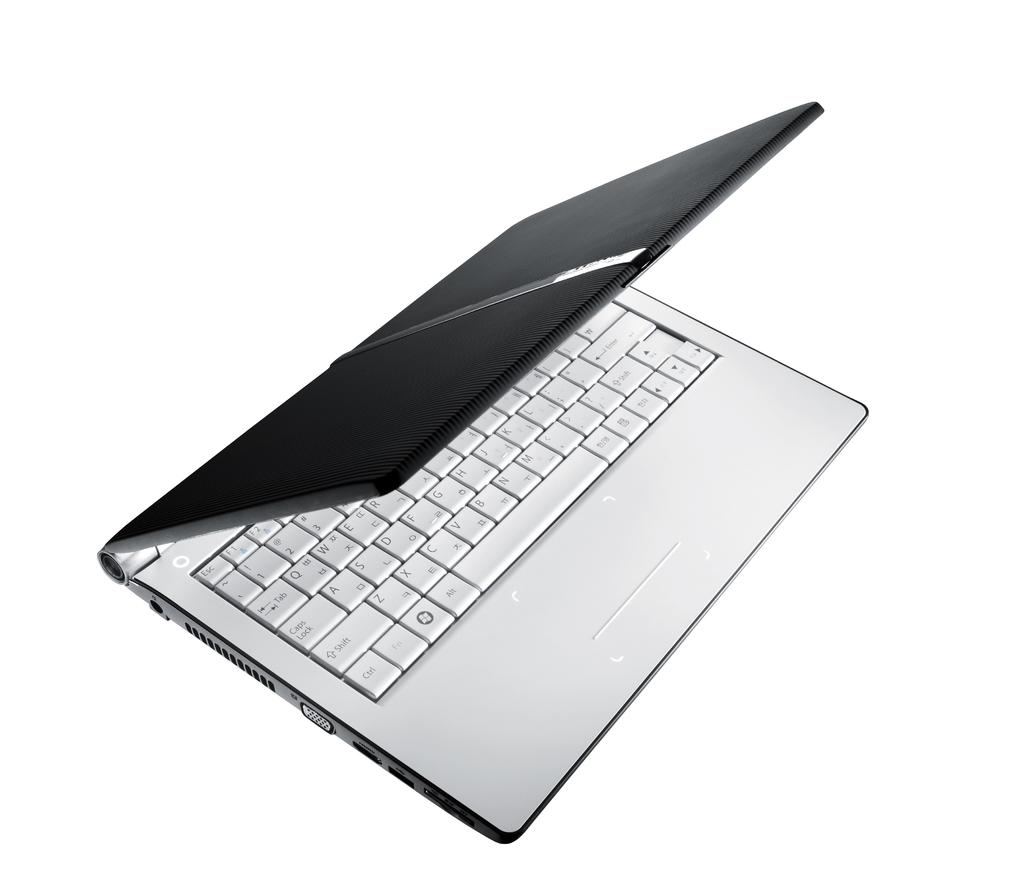<image>
Summarize the visual content of the image. The laptop is showing the keyboard with all of the keys including shift and caps lock. 